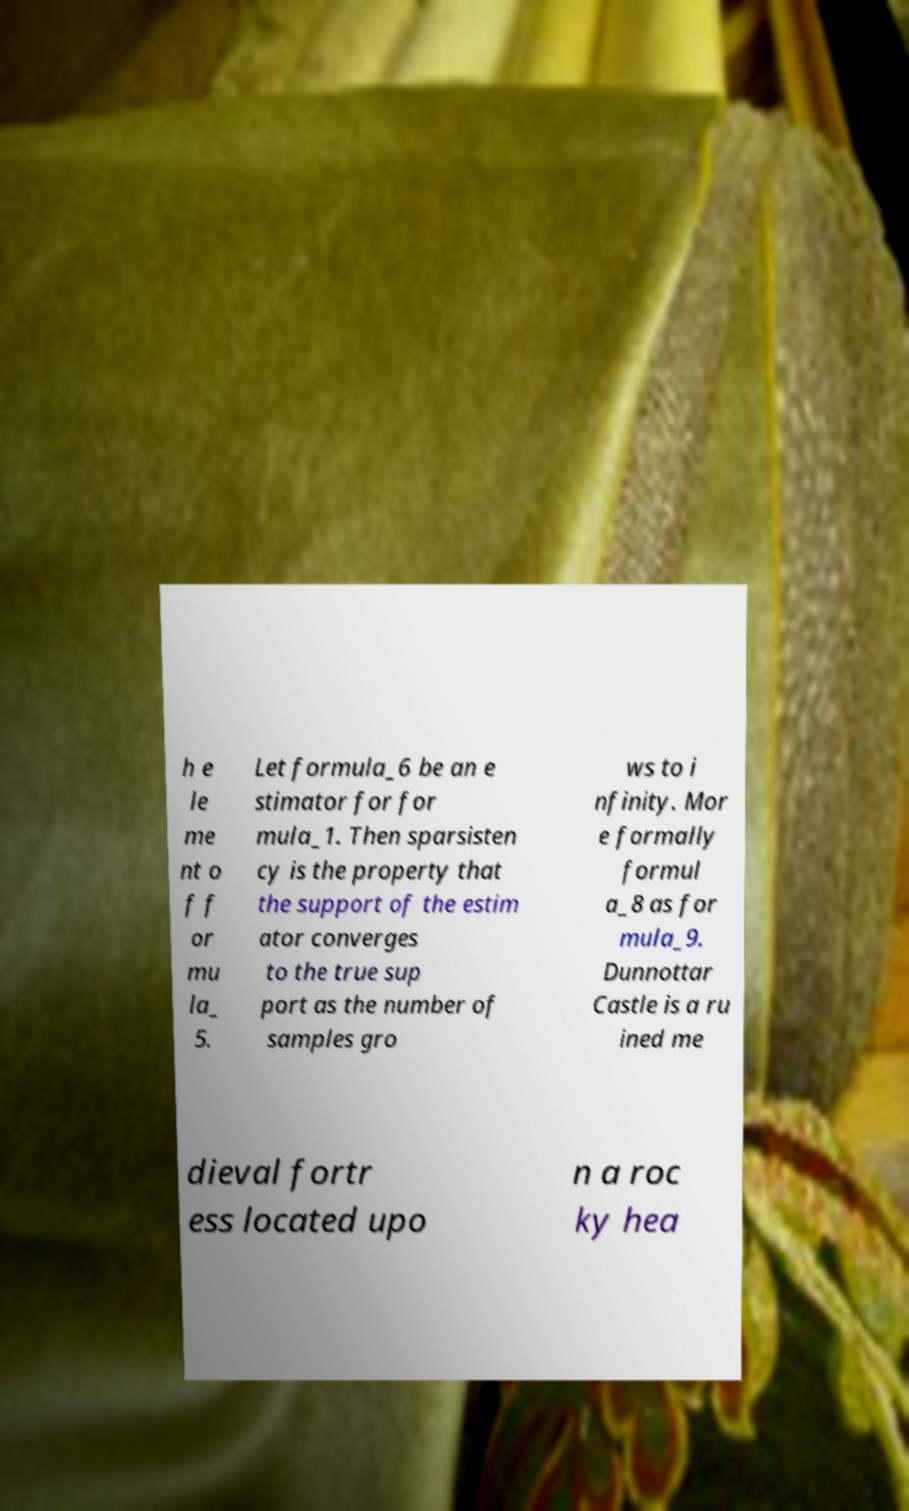I need the written content from this picture converted into text. Can you do that? h e le me nt o f f or mu la_ 5. Let formula_6 be an e stimator for for mula_1. Then sparsisten cy is the property that the support of the estim ator converges to the true sup port as the number of samples gro ws to i nfinity. Mor e formally formul a_8 as for mula_9. Dunnottar Castle is a ru ined me dieval fortr ess located upo n a roc ky hea 